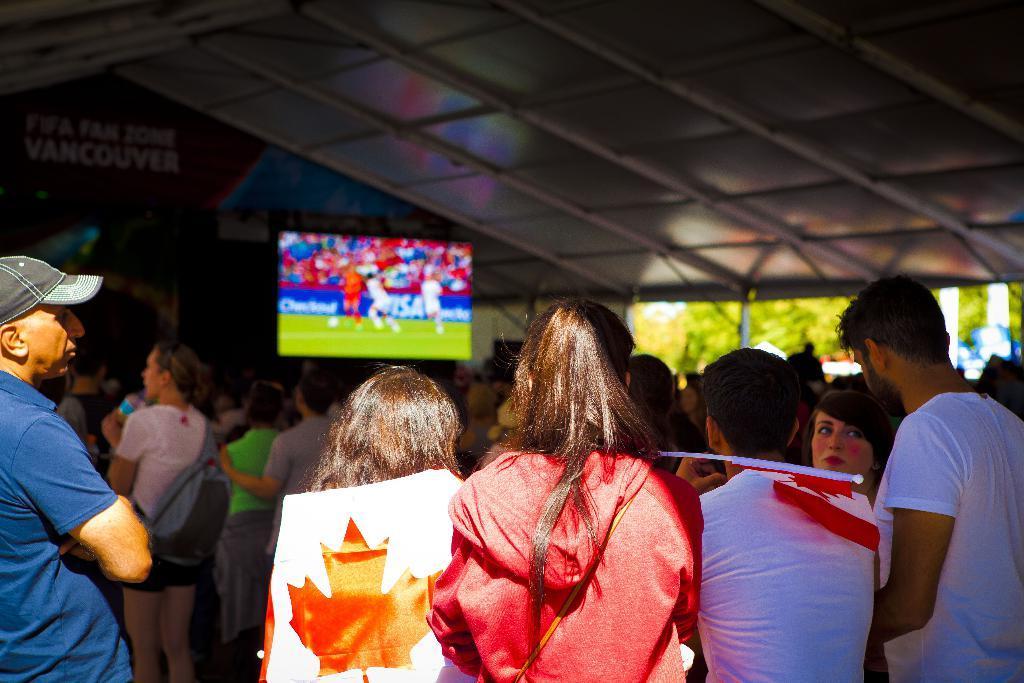Could you give a brief overview of what you see in this image? In this picture, we can see a few people, flag, television, shed, trees, poles, and blurred background. 